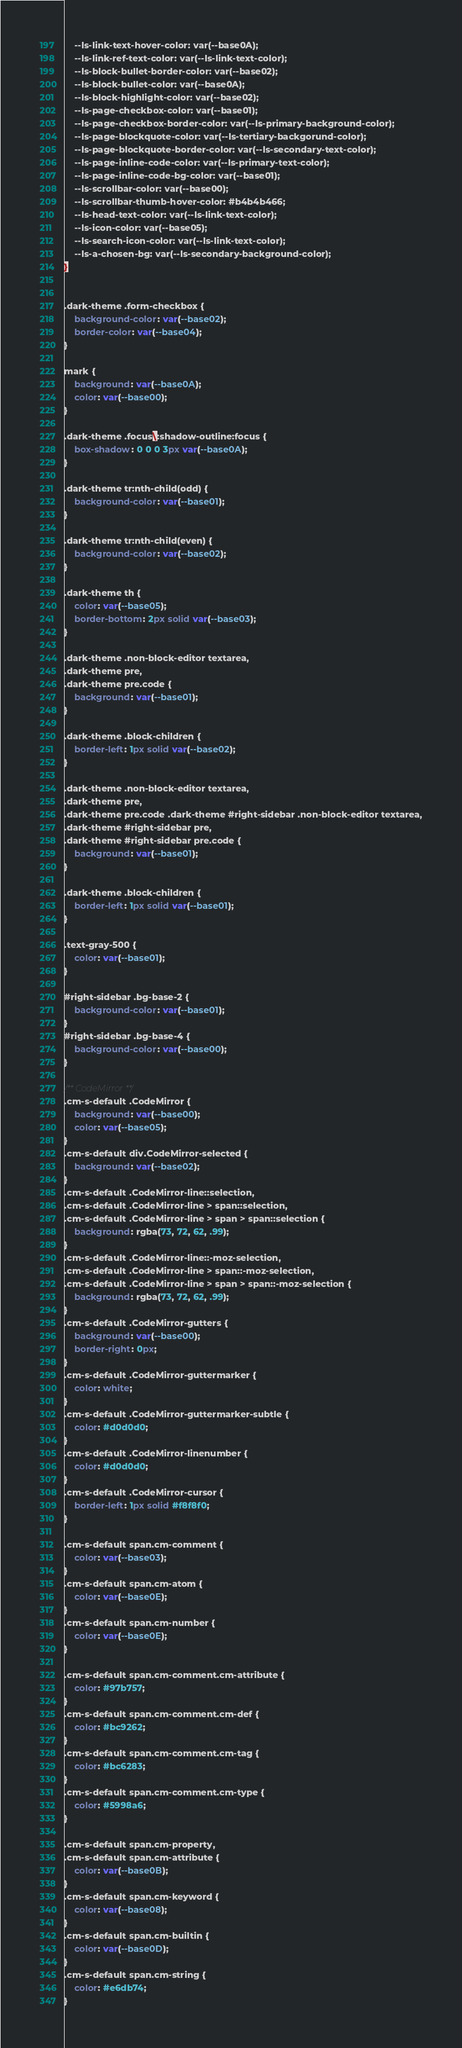Convert code to text. <code><loc_0><loc_0><loc_500><loc_500><_CSS_>    --ls-link-text-hover-color: var(--base0A);
    --ls-link-ref-text-color: var(--ls-link-text-color);
    --ls-block-bullet-border-color: var(--base02);
    --ls-block-bullet-color: var(--base0A);
    --ls-block-highlight-color: var(--base02);
    --ls-page-checkbox-color: var(--base01);
    --ls-page-checkbox-border-color: var(--ls-primary-background-color);
    --ls-page-blockquote-color: var(--ls-tertiary-backgorund-color);
    --ls-page-blockquote-border-color: var(--ls-secondary-text-color);
    --ls-page-inline-code-color: var(--ls-primary-text-color);
    --ls-page-inline-code-bg-color: var(--base01);
    --ls-scrollbar-color: var(--base00);
    --ls-scrollbar-thumb-hover-color: #b4b4b466;
    --ls-head-text-color: var(--ls-link-text-color);
    --ls-icon-color: var(--base05);
    --ls-search-icon-color: var(--ls-link-text-color);
    --ls-a-chosen-bg: var(--ls-secondary-background-color);
}


.dark-theme .form-checkbox {
    background-color: var(--base02);
    border-color: var(--base04);
}

mark {
    background: var(--base0A);
    color: var(--base00);
}

.dark-theme .focus\:shadow-outline:focus {
    box-shadow: 0 0 0 3px var(--base0A);
}

.dark-theme tr:nth-child(odd) {
    background-color: var(--base01);
}

.dark-theme tr:nth-child(even) {
    background-color: var(--base02);
}

.dark-theme th {
    color: var(--base05);
    border-bottom: 2px solid var(--base03);
}

.dark-theme .non-block-editor textarea,
.dark-theme pre,
.dark-theme pre.code {
    background: var(--base01);
}

.dark-theme .block-children {
    border-left: 1px solid var(--base02);
}

.dark-theme .non-block-editor textarea,
.dark-theme pre,
.dark-theme pre.code .dark-theme #right-sidebar .non-block-editor textarea,
.dark-theme #right-sidebar pre,
.dark-theme #right-sidebar pre.code {
    background: var(--base01);
}

.dark-theme .block-children {
    border-left: 1px solid var(--base01);
}

.text-gray-500 {
    color: var(--base01);
}

#right-sidebar .bg-base-2 {
    background-color: var(--base01);
}
#right-sidebar .bg-base-4 {
    background-color: var(--base00);
}

/** CodeMirror **/
.cm-s-default .CodeMirror {
    background: var(--base00);
    color: var(--base05);
}
.cm-s-default div.CodeMirror-selected {
    background: var(--base02);
}
.cm-s-default .CodeMirror-line::selection,
.cm-s-default .CodeMirror-line > span::selection,
.cm-s-default .CodeMirror-line > span > span::selection {
    background: rgba(73, 72, 62, .99);
}
.cm-s-default .CodeMirror-line::-moz-selection,
.cm-s-default .CodeMirror-line > span::-moz-selection,
.cm-s-default .CodeMirror-line > span > span::-moz-selection {
    background: rgba(73, 72, 62, .99);
}
.cm-s-default .CodeMirror-gutters {
    background: var(--base00);
    border-right: 0px;
}
.cm-s-default .CodeMirror-guttermarker {
    color: white;
}
.cm-s-default .CodeMirror-guttermarker-subtle {
    color: #d0d0d0;
}
.cm-s-default .CodeMirror-linenumber {
    color: #d0d0d0;
}
.cm-s-default .CodeMirror-cursor {
    border-left: 1px solid #f8f8f0;
}

.cm-s-default span.cm-comment {
    color: var(--base03);
}
.cm-s-default span.cm-atom {
    color: var(--base0E);
}
.cm-s-default span.cm-number {
    color: var(--base0E);
}

.cm-s-default span.cm-comment.cm-attribute {
    color: #97b757;
}
.cm-s-default span.cm-comment.cm-def {
    color: #bc9262;
}
.cm-s-default span.cm-comment.cm-tag {
    color: #bc6283;
}
.cm-s-default span.cm-comment.cm-type {
    color: #5998a6;
}

.cm-s-default span.cm-property,
.cm-s-default span.cm-attribute {
    color: var(--base0B);
}
.cm-s-default span.cm-keyword {
    color: var(--base08);
}
.cm-s-default span.cm-builtin {
    color: var(--base0D);
}
.cm-s-default span.cm-string {
    color: #e6db74;
}
</code> 